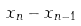Convert formula to latex. <formula><loc_0><loc_0><loc_500><loc_500>x _ { n } - x _ { n - 1 }</formula> 